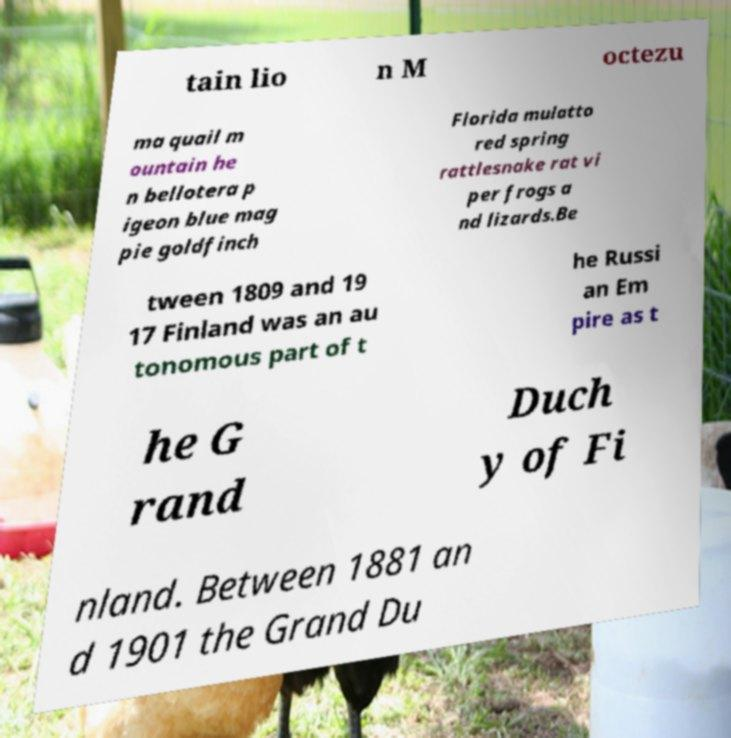I need the written content from this picture converted into text. Can you do that? tain lio n M octezu ma quail m ountain he n bellotera p igeon blue mag pie goldfinch Florida mulatto red spring rattlesnake rat vi per frogs a nd lizards.Be tween 1809 and 19 17 Finland was an au tonomous part of t he Russi an Em pire as t he G rand Duch y of Fi nland. Between 1881 an d 1901 the Grand Du 